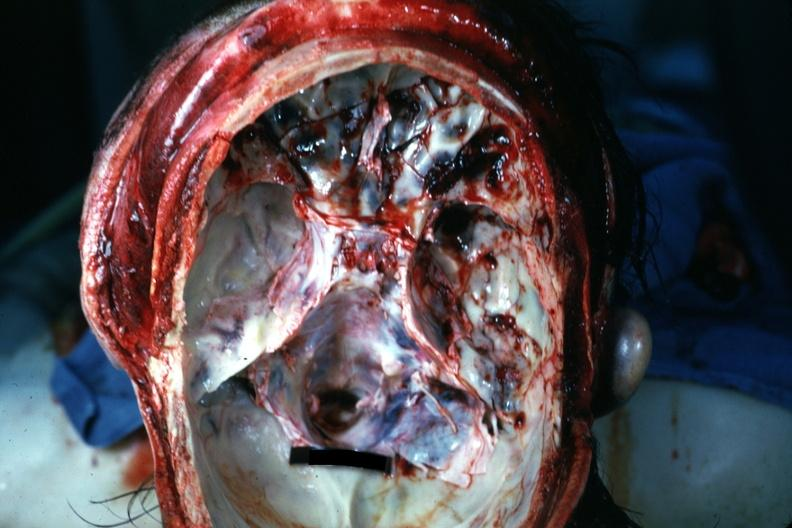s acute peritonitis present?
Answer the question using a single word or phrase. No 